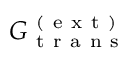<formula> <loc_0><loc_0><loc_500><loc_500>G _ { t r a n s } ^ { ( e x t ) }</formula> 